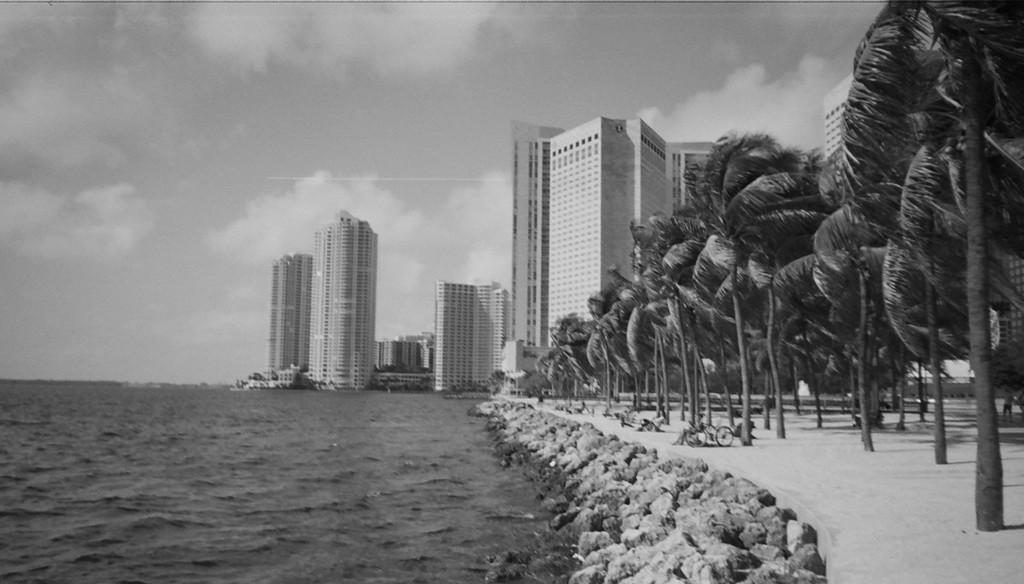What is the color scheme of the image? The image is black and white. What natural element can be seen in the image? Water is visible in the image. What type of geological feature is present in the image? Rocks are present in the image. What type of vegetation is visible in the image? Trees are visible in the image. What man-made structure can be seen in the image? There is a tower in the image. What type of buildings are present in the image? Buildings are present in the image. What is visible in the background of the image? The sky is visible in the background of the image. What atmospheric feature can be seen in the sky? Clouds are present in the sky. How many screws can be seen holding the tower together in the image? There are no screws visible in the image; the tower is a solid structure. 